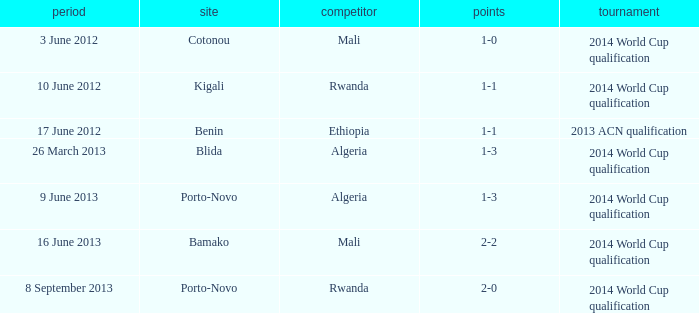What is the score from the game where Algeria is the opponent at Porto-Novo? 1-3. 